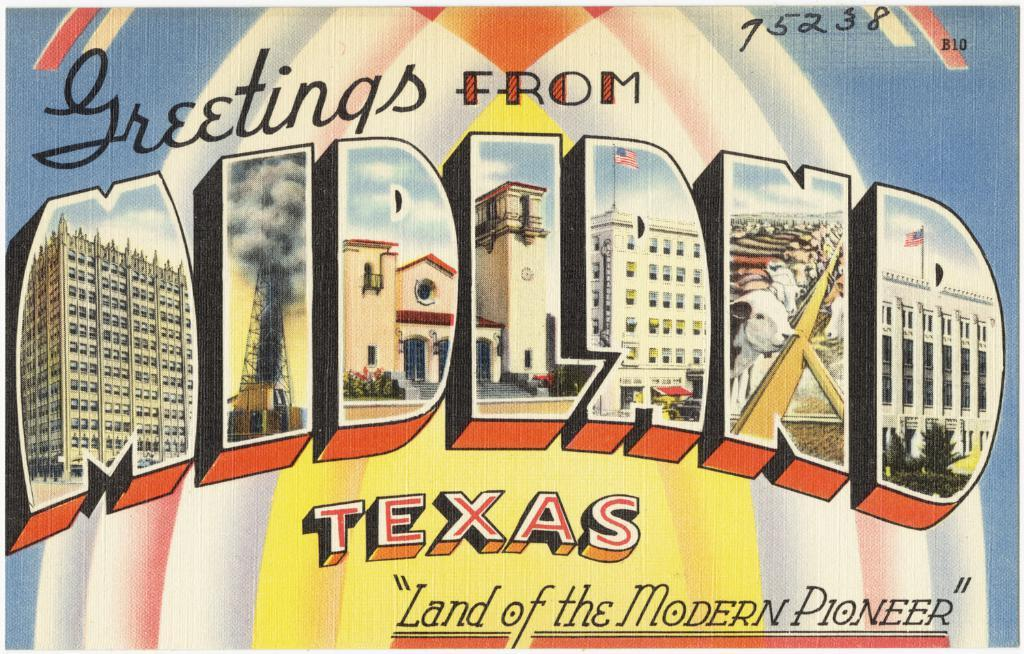<image>
Summarize the visual content of the image. A postcard that reads greetings from Midland Texas, land of the Modern Pioneer. 